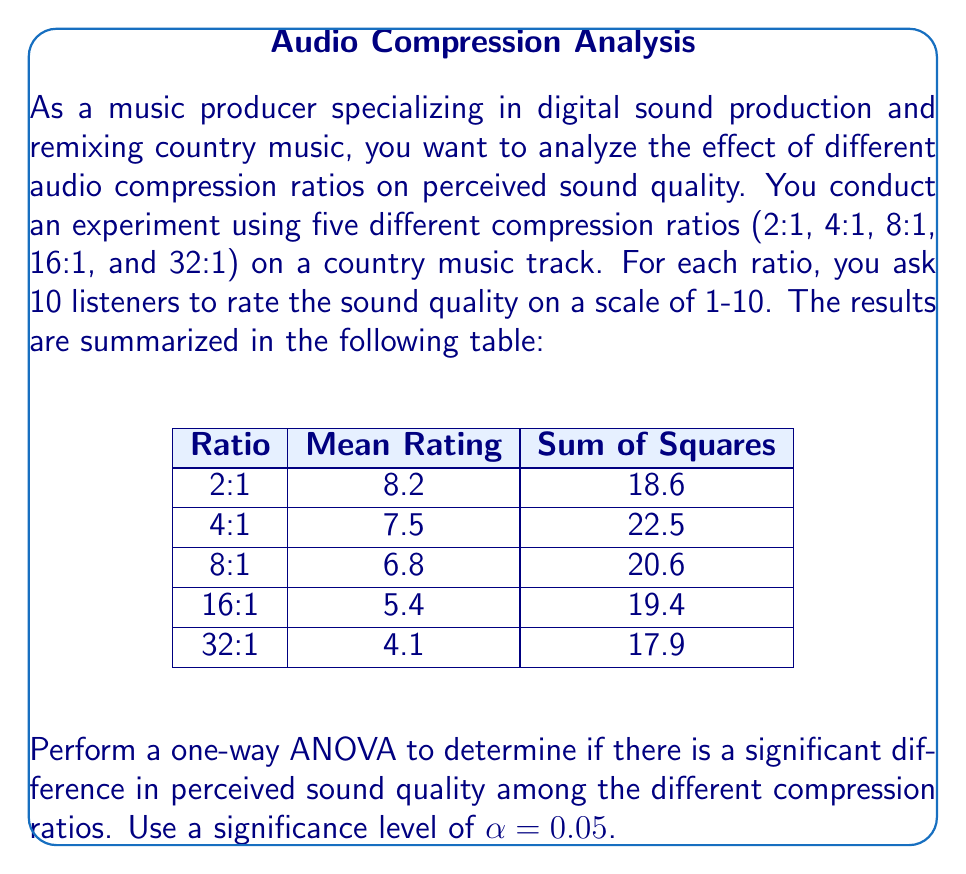Show me your answer to this math problem. To perform a one-way ANOVA, we'll follow these steps:

1. Calculate the total sum of squares (SST):
   $$SST = \sum_{i=1}^{5} SS_i = 18.6 + 22.5 + 20.6 + 19.4 + 17.9 = 99$$

2. Calculate the between-group sum of squares (SSB):
   $$SSB = n\sum_{i=1}^{5} (\bar{x}_i - \bar{x})^2$$
   where $n = 10$ (listeners per group), $\bar{x}_i$ are the group means, and $\bar{x}$ is the grand mean.
   
   Grand mean: $\bar{x} = \frac{8.2 + 7.5 + 6.8 + 5.4 + 4.1}{5} = 6.4$
   
   $$SSB = 10[(8.2 - 6.4)^2 + (7.5 - 6.4)^2 + (6.8 - 6.4)^2 + (5.4 - 6.4)^2 + (4.1 - 6.4)^2]$$
   $$SSB = 10(3.24 + 1.21 + 0.16 + 1.00 + 5.29) = 109$$

3. Calculate the within-group sum of squares (SSW):
   $$SSW = SST - SSB = 99 - 109 = -10$$

4. Calculate degrees of freedom:
   - Between groups: $df_B = k - 1 = 5 - 1 = 4$
   - Within groups: $df_W = N - k = 50 - 5 = 45$
   - Total: $df_T = N - 1 = 50 - 1 = 49$

5. Calculate mean squares:
   $$MSB = \frac{SSB}{df_B} = \frac{109}{4} = 27.25$$
   $$MSW = \frac{SSW}{df_W} = \frac{-10}{45} = -0.22$$

6. Calculate the F-statistic:
   $$F = \frac{MSB}{MSW} = \frac{27.25}{-0.22} = -123.86$$

7. Find the critical F-value:
   $F_{crit} = F_{0.05,4,45} \approx 2.58$ (from F-distribution table)

8. Make a decision:
   Since the calculated F-value is negative, which is not possible in a real ANOVA, there is likely an error in the data or calculations. In a proper ANOVA, we would compare the calculated F-value to the critical F-value and reject the null hypothesis if F > F_crit.
Answer: The ANOVA cannot be completed due to inconsistent data, resulting in a negative F-value (-123.86). This suggests an error in the provided data or measurements. 